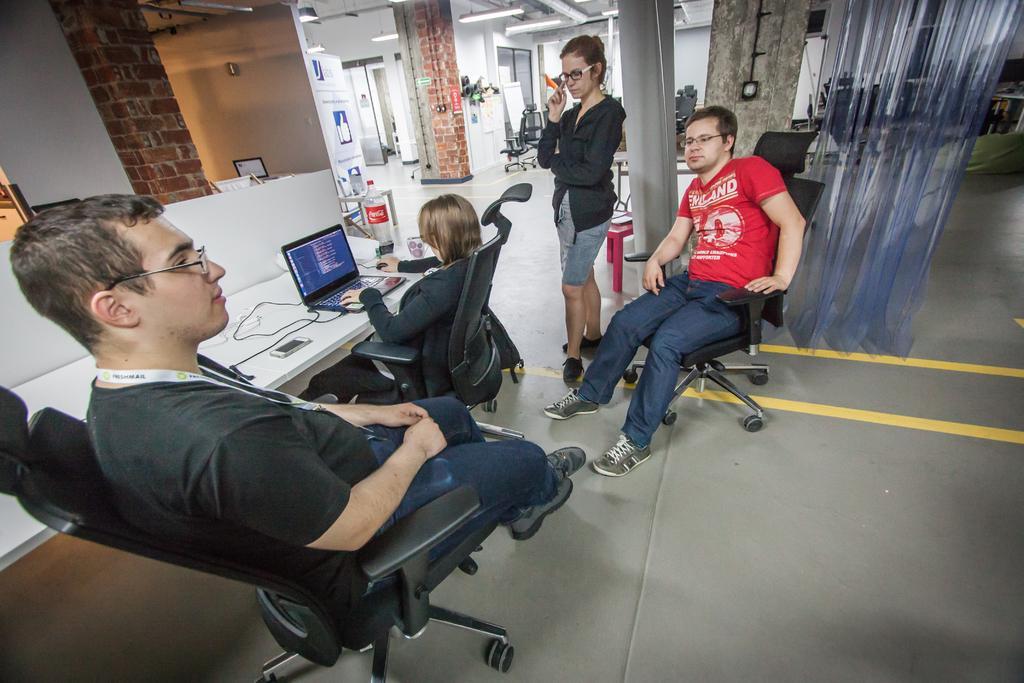Can you describe this image briefly? This 3 persons are sitting on a chair. This woman is standing. On this table there is a mobile, cables, laptop and bottle. Far there is a monitor. Far we can able to see chairs. This is curtain. 